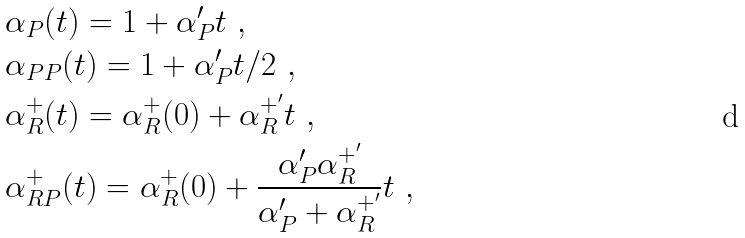<formula> <loc_0><loc_0><loc_500><loc_500>\ & \alpha _ { P } ( t ) = 1 + \alpha _ { P } ^ { \prime } t \ , \\ & \alpha _ { P P } ( t ) = 1 + \alpha _ { P } ^ { \prime } t / 2 \ , \\ & \alpha _ { R } ^ { + } ( t ) = \alpha _ { R } ^ { + } ( 0 ) + \alpha _ { R } ^ { + ^ { \prime } } t \ , \\ & \alpha _ { R P } ^ { + } ( t ) = \alpha _ { R } ^ { + } ( 0 ) + \frac { \alpha _ { P } ^ { \prime } \alpha _ { R } ^ { + ^ { \prime } } } { \alpha _ { P } ^ { \prime } + \alpha _ { R } ^ { + ^ { \prime } } } t \ ,</formula> 